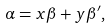Convert formula to latex. <formula><loc_0><loc_0><loc_500><loc_500>\alpha = x \beta + y \beta ^ { \prime } ,</formula> 